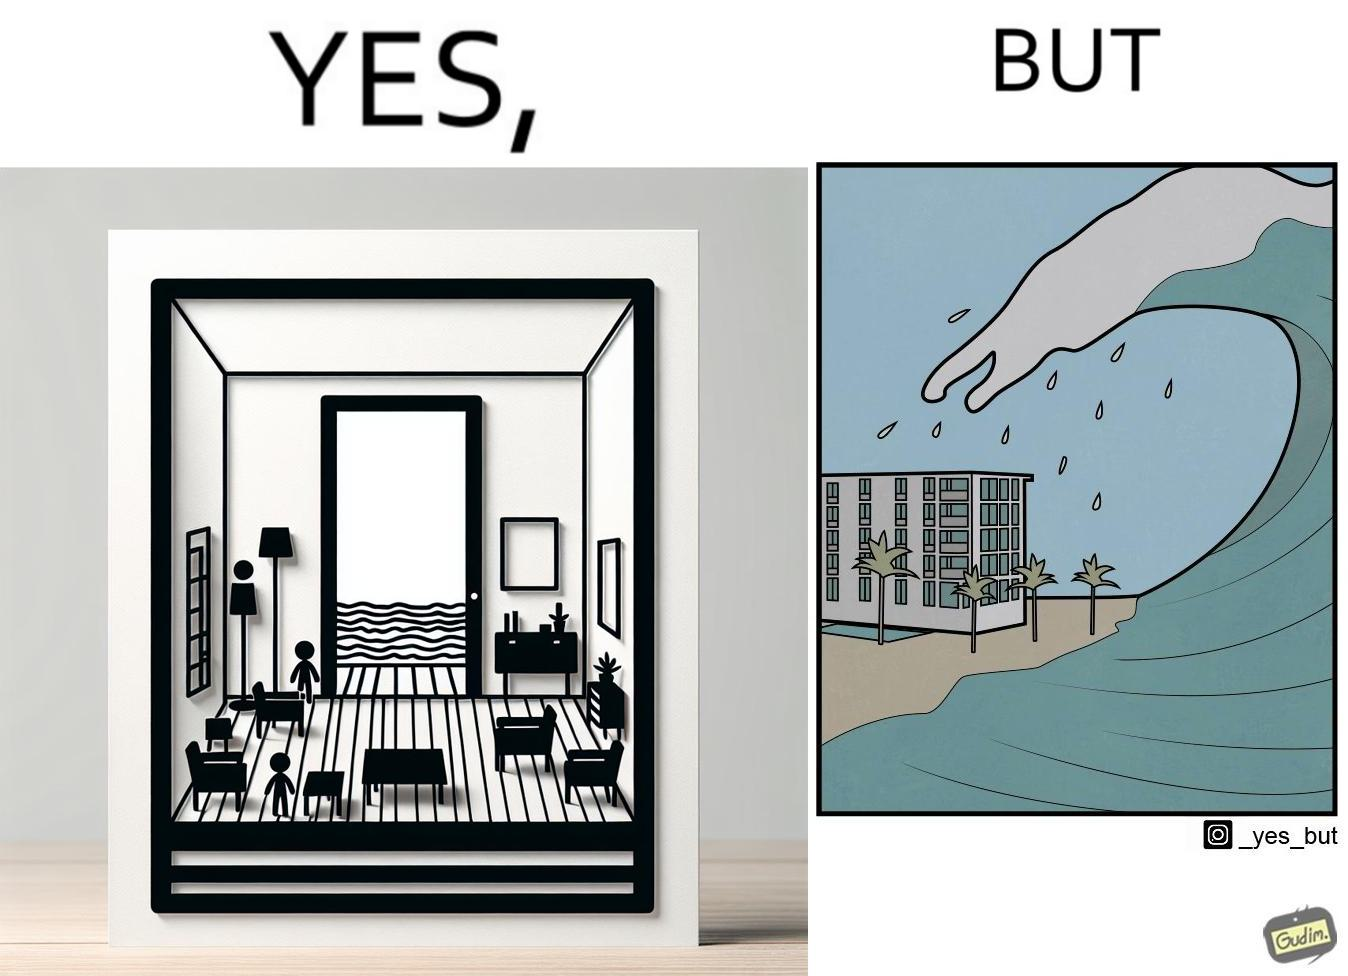Describe the satirical element in this image. The same sea which gives us a relaxation on a normal day can pose a danger to us sometimes like during a tsunami 